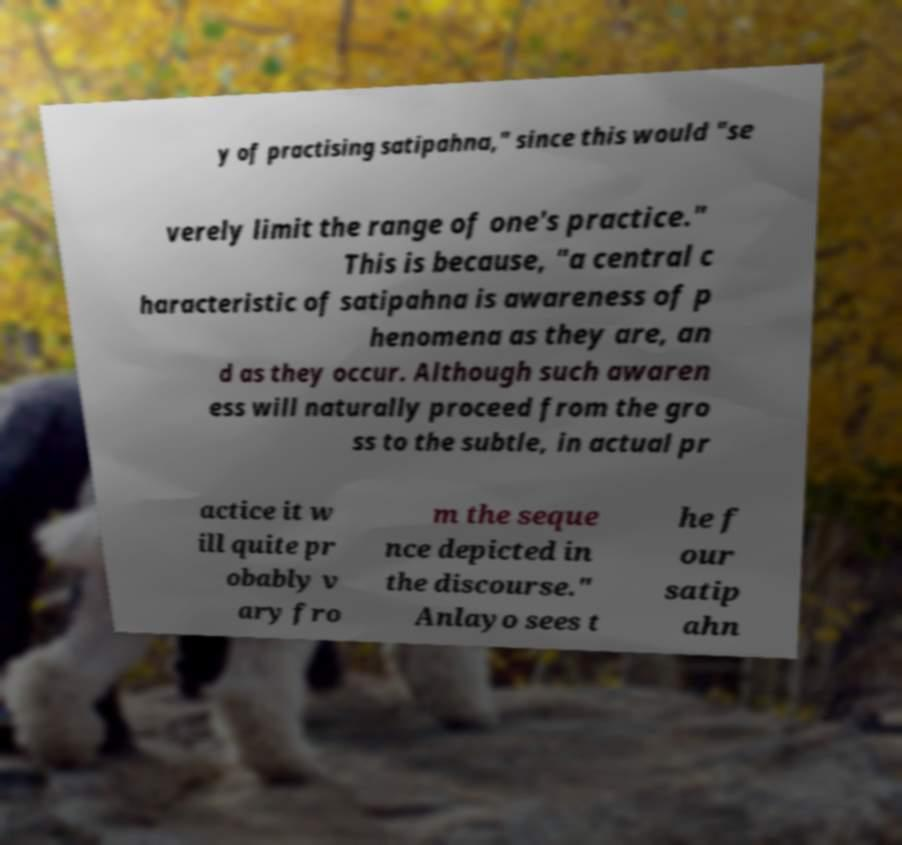I need the written content from this picture converted into text. Can you do that? y of practising satipahna," since this would "se verely limit the range of one's practice." This is because, "a central c haracteristic of satipahna is awareness of p henomena as they are, an d as they occur. Although such awaren ess will naturally proceed from the gro ss to the subtle, in actual pr actice it w ill quite pr obably v ary fro m the seque nce depicted in the discourse." Anlayo sees t he f our satip ahn 